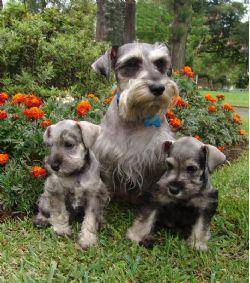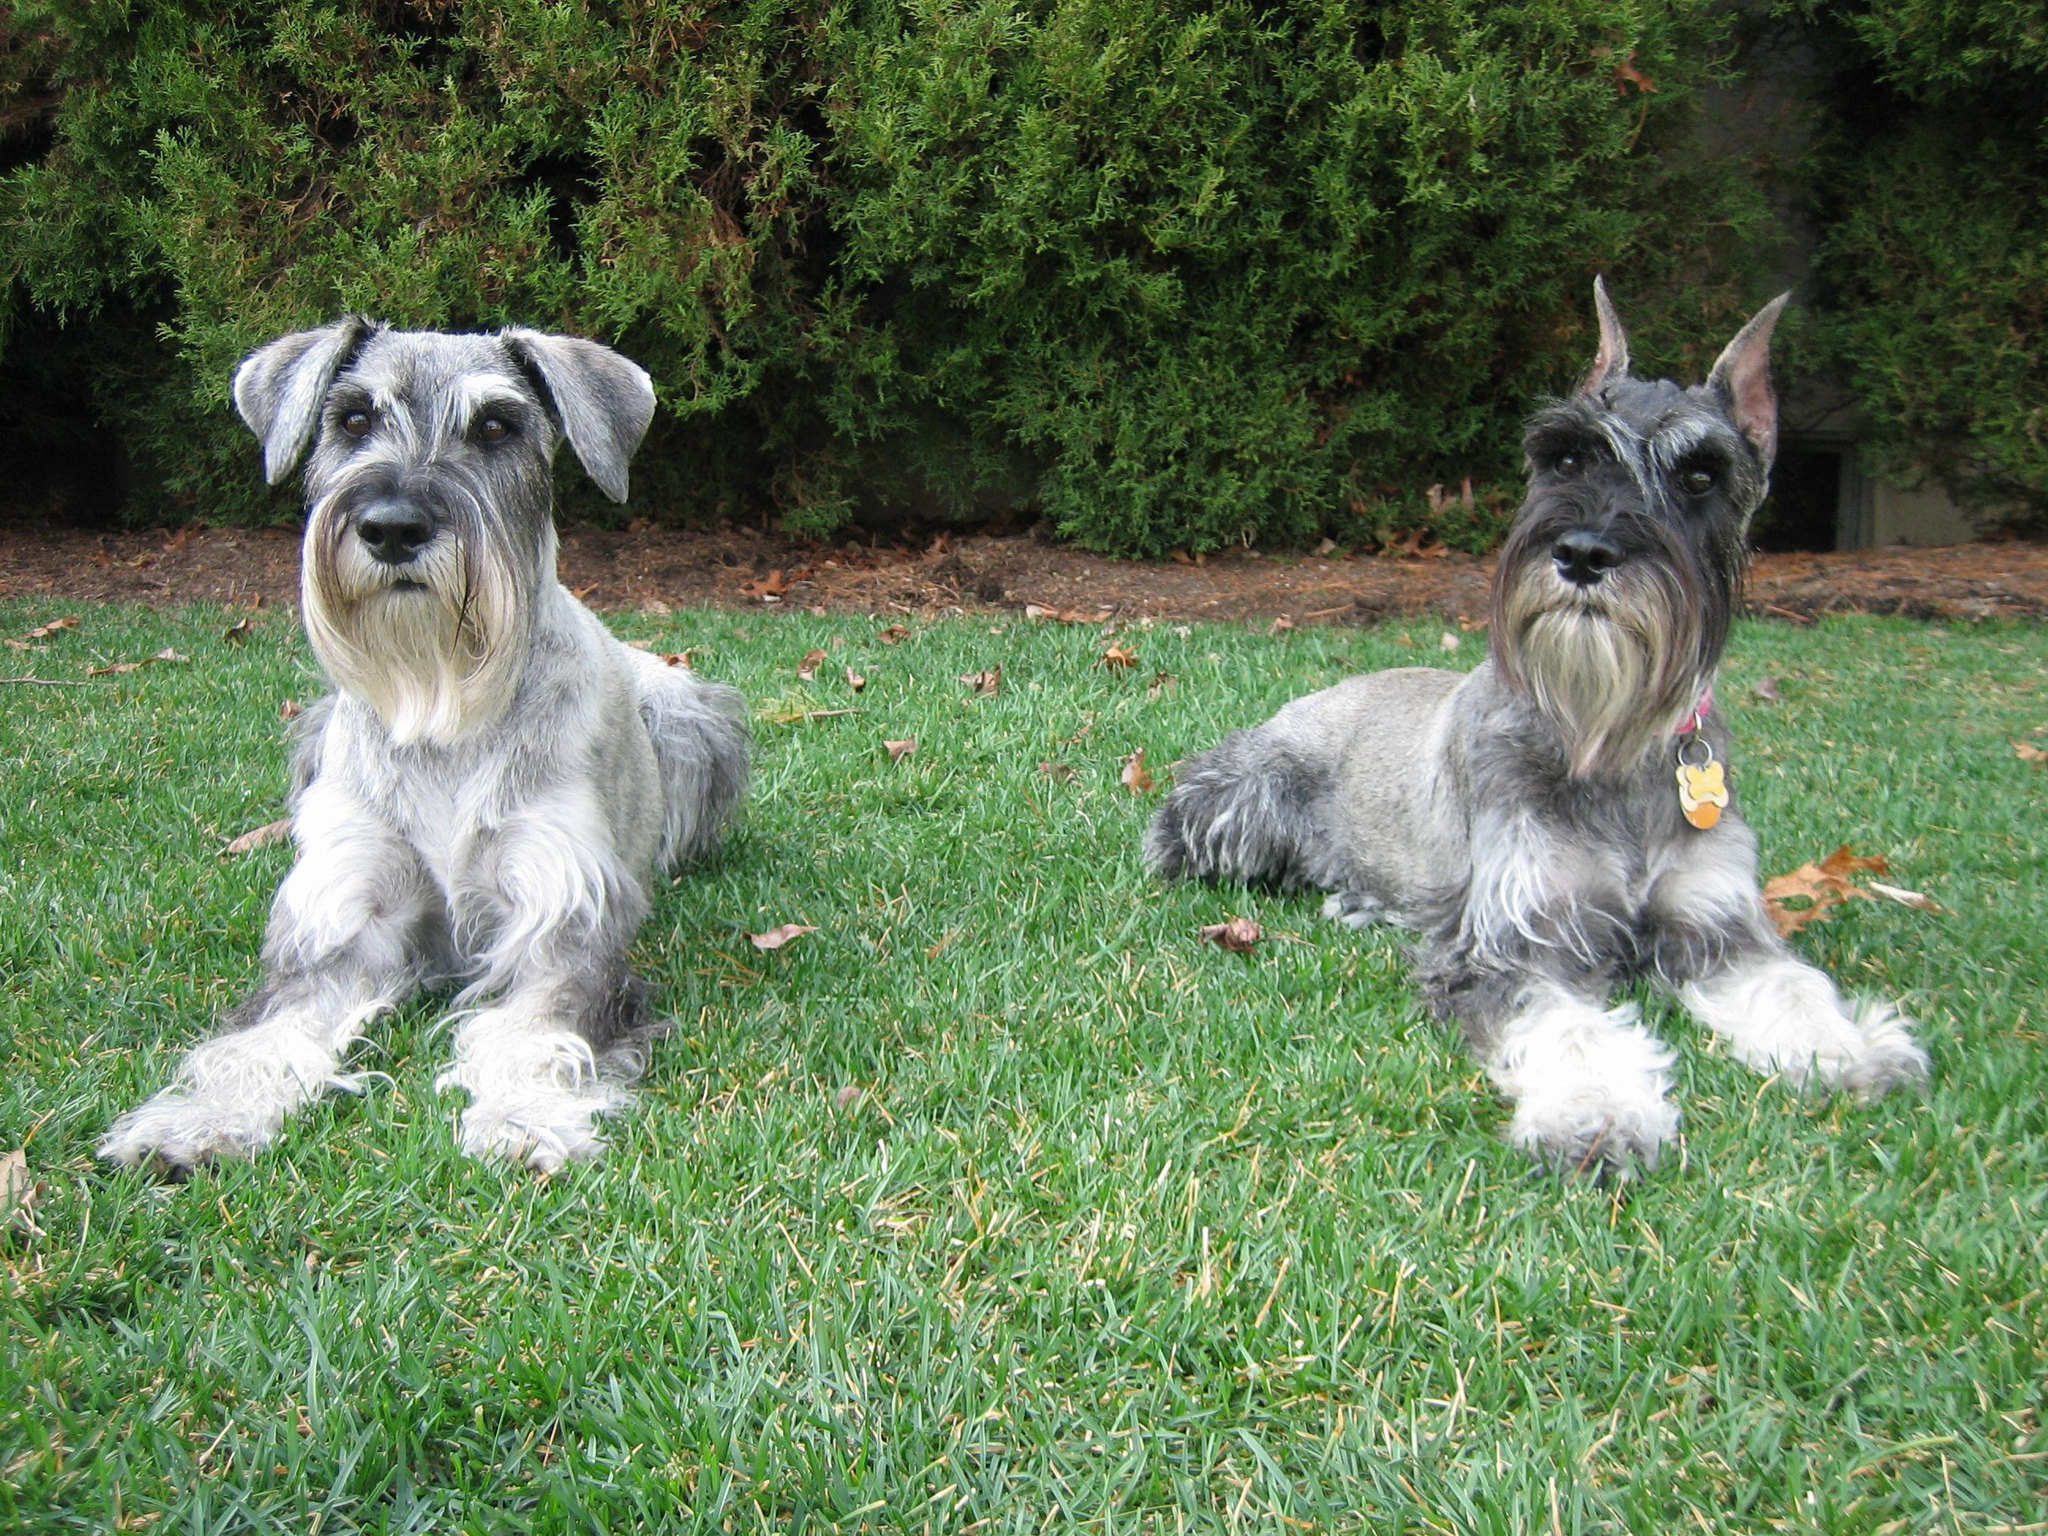The first image is the image on the left, the second image is the image on the right. For the images displayed, is the sentence "There are no more than four dogs" factually correct? Answer yes or no. No. 